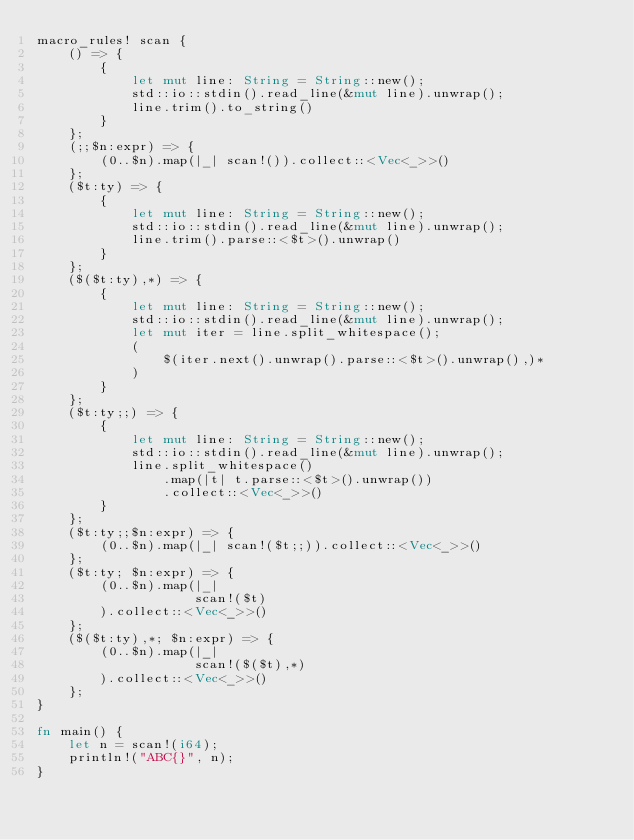<code> <loc_0><loc_0><loc_500><loc_500><_Rust_>macro_rules! scan {
    () => {
        {
            let mut line: String = String::new();
            std::io::stdin().read_line(&mut line).unwrap();
            line.trim().to_string()
        }
    };
    (;;$n:expr) => {
        (0..$n).map(|_| scan!()).collect::<Vec<_>>()
    };
    ($t:ty) => {
        {
            let mut line: String = String::new();
            std::io::stdin().read_line(&mut line).unwrap();
            line.trim().parse::<$t>().unwrap()
        }
    };
    ($($t:ty),*) => {
        {
            let mut line: String = String::new();
            std::io::stdin().read_line(&mut line).unwrap();
            let mut iter = line.split_whitespace();
            (
                $(iter.next().unwrap().parse::<$t>().unwrap(),)*
            )
        }
    };
    ($t:ty;;) => {
        {
            let mut line: String = String::new();
            std::io::stdin().read_line(&mut line).unwrap();
            line.split_whitespace()
                .map(|t| t.parse::<$t>().unwrap())
                .collect::<Vec<_>>()
        }
    };
    ($t:ty;;$n:expr) => {
        (0..$n).map(|_| scan!($t;;)).collect::<Vec<_>>()
    };
    ($t:ty; $n:expr) => {
        (0..$n).map(|_|
                    scan!($t)
        ).collect::<Vec<_>>()
    };
    ($($t:ty),*; $n:expr) => {
        (0..$n).map(|_|
                    scan!($($t),*)
        ).collect::<Vec<_>>()
    };
}

fn main() {
    let n = scan!(i64);
    println!("ABC{}", n);
}
</code> 